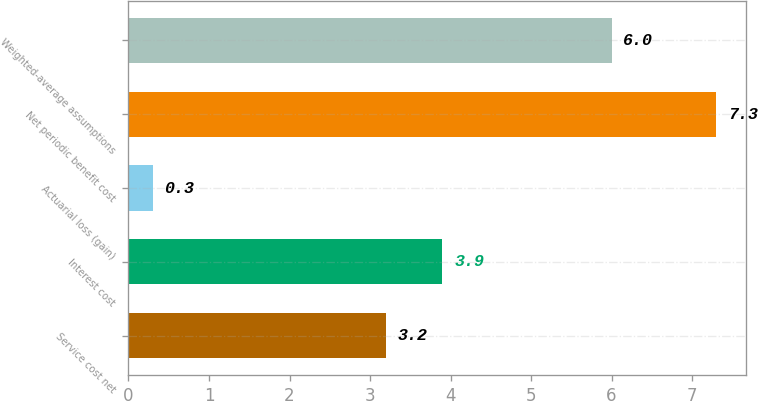<chart> <loc_0><loc_0><loc_500><loc_500><bar_chart><fcel>Service cost net<fcel>Interest cost<fcel>Actuarial loss (gain)<fcel>Net periodic benefit cost<fcel>Weighted-average assumptions<nl><fcel>3.2<fcel>3.9<fcel>0.3<fcel>7.3<fcel>6<nl></chart> 